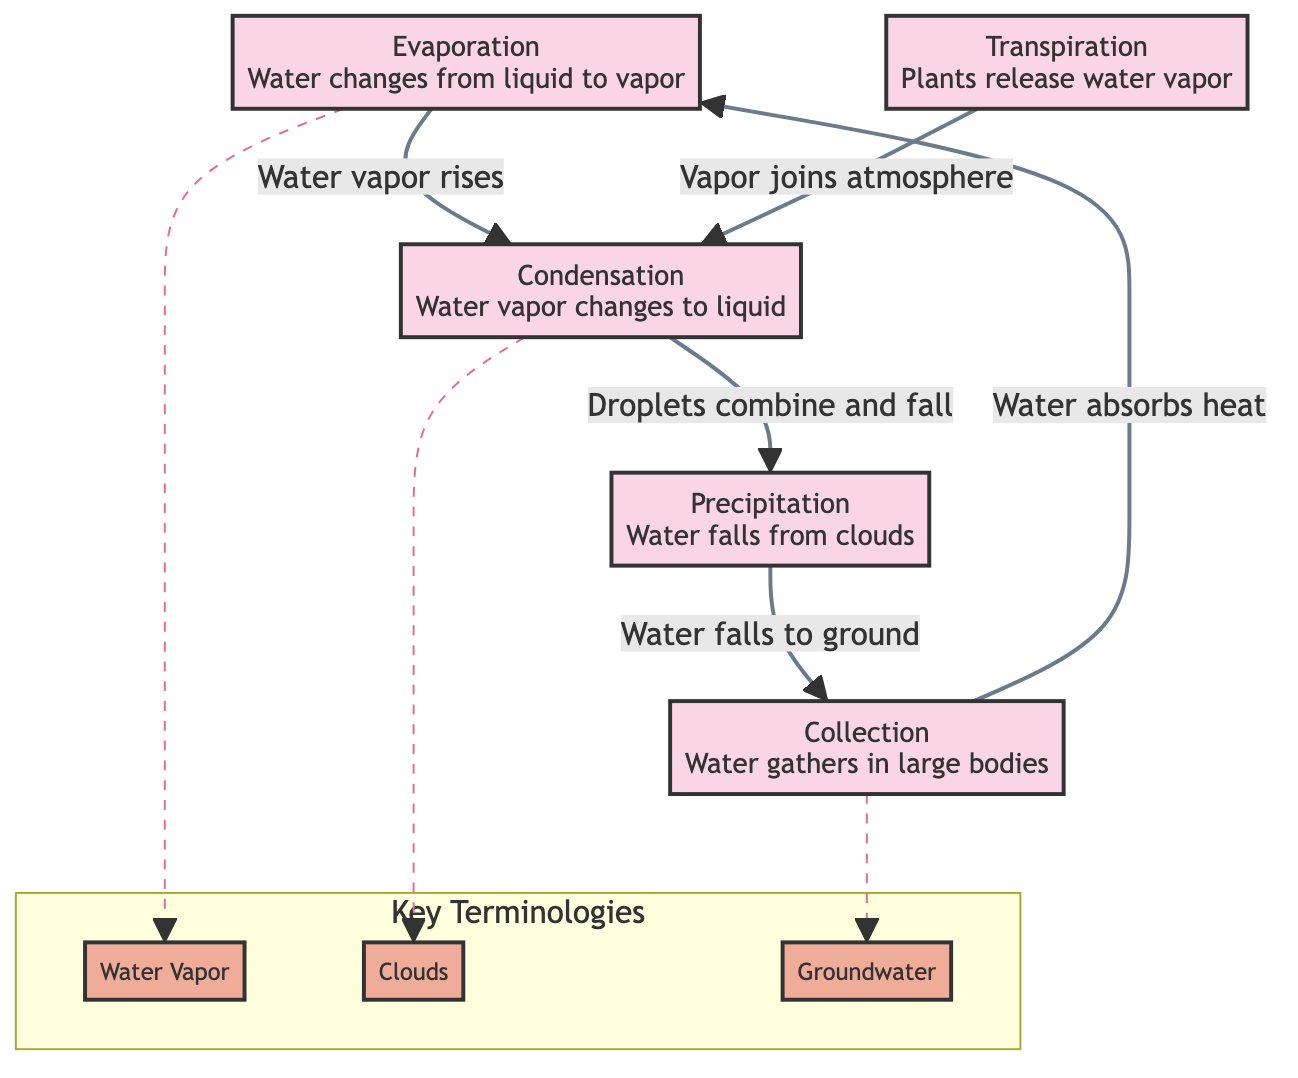What is the first process in the water cycle diagram? The diagram outlines the water cycle starting with the 'Evaporation' process as the first step, indicated by the arrow directing from 'Evaporation' to 'Condensation'.
Answer: Evaporation How many connections are illustrated between the processes? Counting the arrows that connect the blocks, there are five connections shown in the diagram: Evaporation to Condensation, Transpiration to Condensation, Condensation to Precipitation, Precipitation to Collection, and Collection to Evaporation.
Answer: 5 What is the process that occurs after condensation? Following the 'Condensation' block, the arrows direct to 'Precipitation', indicating that precipitation is the next step in the cycle after condensation occurs.
Answer: Precipitation Which process involves the release of water vapor from plants? The 'Transpiration' block describes the process of plants releasing water vapor, and it is the only block that focuses on this specific aspect of the water cycle.
Answer: Transpiration What do water droplets in clouds do according to the diagram? The diagram indicates through the connection from 'Condensation' to 'Precipitation' that water droplets in clouds combine and fall as precipitation when they become heavy enough.
Answer: Combine and fall How does water return to the evaporation process after precipitation? After the precipitation occurs and water falls to the ground, it accumulates in large bodies of water, which is represented by the 'Collection' block that is then linked back to 'Evaporation' showing the cycle's continuity.
Answer: Water absorbs heat What terminology describes the gaseous form of water? In the section labeled 'Key Terminologies', the term 'Water Vapor' is defined as the gaseous form of water created by evaporation, which is directly associated with the process of evaporation in the water cycle.
Answer: Water Vapor What are clouds composed of, according to the diagram? The 'Clouds' terminology is linked with 'Condensation' in the diagram, and it is defined as masses of water droplets or ice crystals suspended in the atmosphere, which form during the condensation phase.
Answer: Water droplets or ice crystals What is the end result of precipitation? The flow from 'Precipitation' to 'Collection' in the diagram directly shows that the outcome of precipitation is that water falls to the ground and accumulates in bodies of water.
Answer: Accumulates in bodies of water 